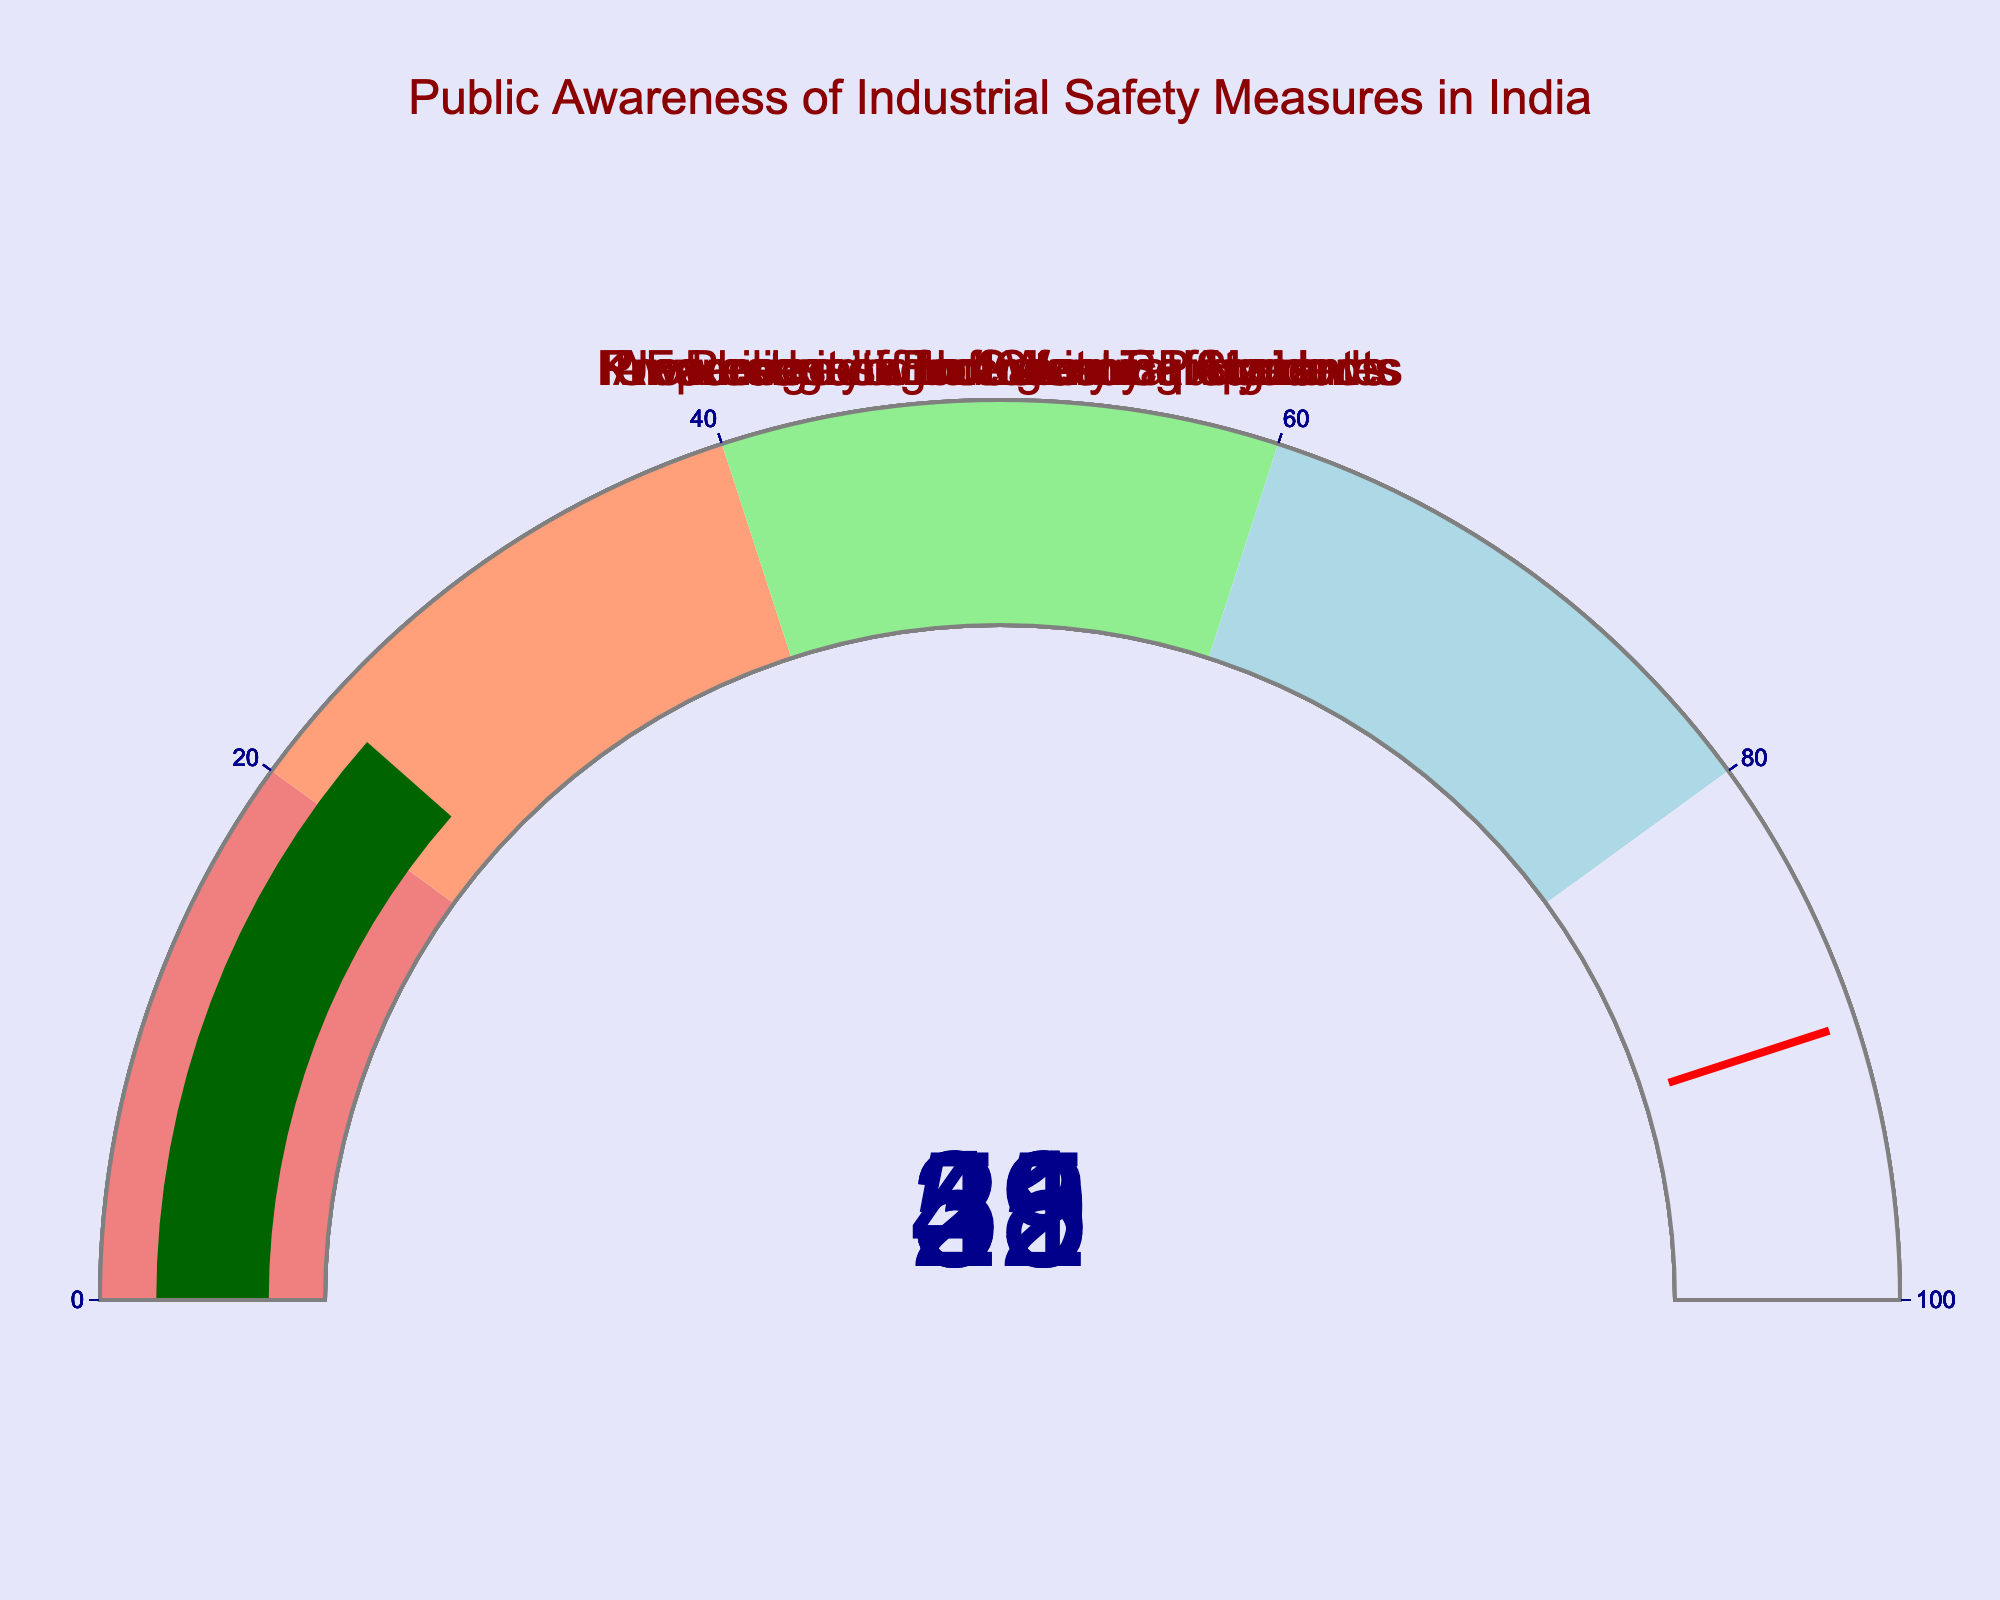What is the value for "Understanding of Chemical Hazards"? The gauge for "Understanding of Chemical Hazards" indicates a value of 45.
Answer: 45 How many metrics have values below 30? "Awareness of Industrial Safety Laws" (32) and "Knowledge of Emergency Procedures" (28) both have values below 30.
Answer: 2 Which metric has the highest level? The gauge for "Recognition of Warning Signs" shows the highest value of 51 among all the metrics.
Answer: "Recognition of Warning Signs" What is the average value across all the metrics? The values are 32, 28, 45, 39, 51, and 23. Summing them gives 218, and dividing by 6 (number of metrics) gives an average of approximately 36.33.
Answer: 36.33 Is the value for "Preparedness for Industrial Accidents" above or below 25? The gauge for "Preparedness for Industrial Accidents" shows a value of 23, which is below 25.
Answer: Below 25 Which metric's awareness level falls into the "lightgreen" range (40-60)? The "Recognition of Warning Signs" and "Understanding of Chemical Hazards" gauges fall into the "lightgreen" range with values of 51 and 45, respectively.
Answer: "Recognition of Warning Signs" and "Understanding of Chemical Hazards" How do the values for "Knowledge of Emergency Procedures" and "Familiarity with Safety Equipment'' compare? "Knowledge of Emergency Procedures" has a value of 28, whereas "Familiarity with Safety Equipment" has a value of 39, so "Knowledge of Emergency Procedures" is lower.
Answer: "Knowledge of Emergency Procedures" is lower What is the difference between the highest and the lowest values? The highest value is 51 ("Recognition of Warning Signs") and the lowest is 23 ("Preparedness for Industrial Accidents"). The difference between them is 51 - 23 = 28.
Answer: 28 Is any metric above the threshold value of 90? All gauge values are visibly below the threshold mark of 90.
Answer: No 